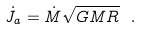Convert formula to latex. <formula><loc_0><loc_0><loc_500><loc_500>\dot { J } _ { a } = \dot { M } \sqrt { G M R } \ .</formula> 